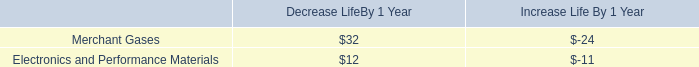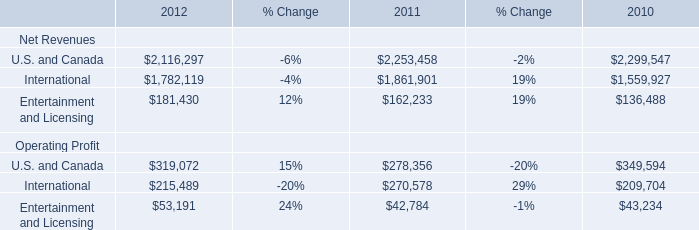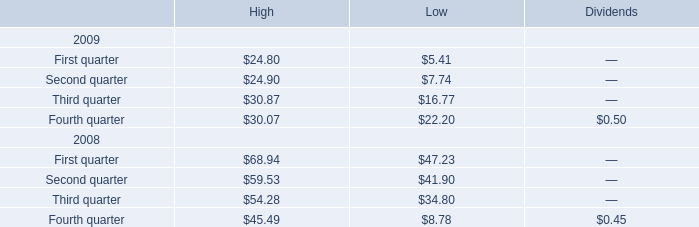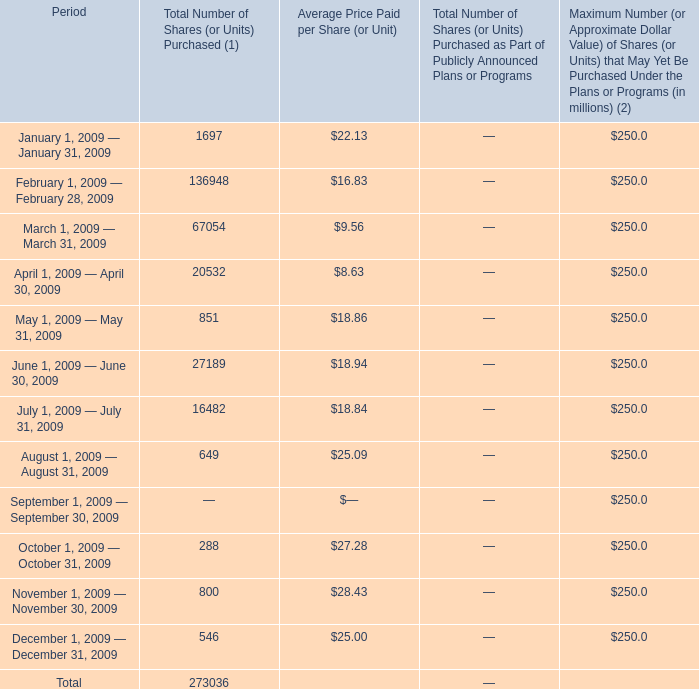In which section the sum of Total Number of Shares has the highest value? 
Answer: February 1, 2009 — February 28, 2009. 